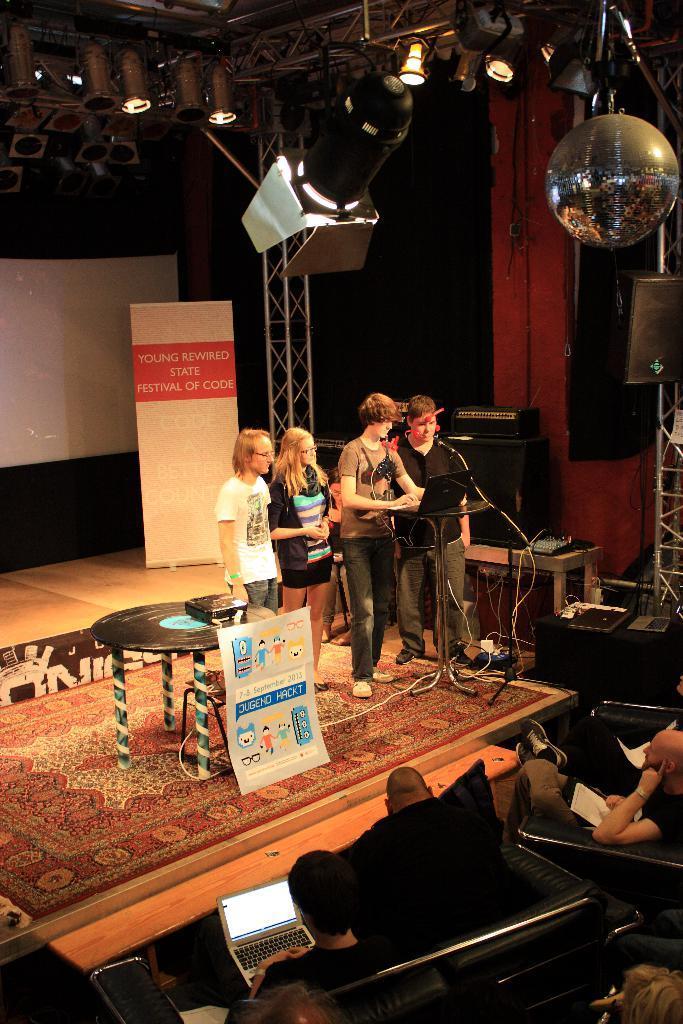Could you give a brief overview of what you see in this image? In the middle 4 persons are standing and looking into the laptop. There are lights at the top, at the bottom few persons are sitting on the sofa chairs. 